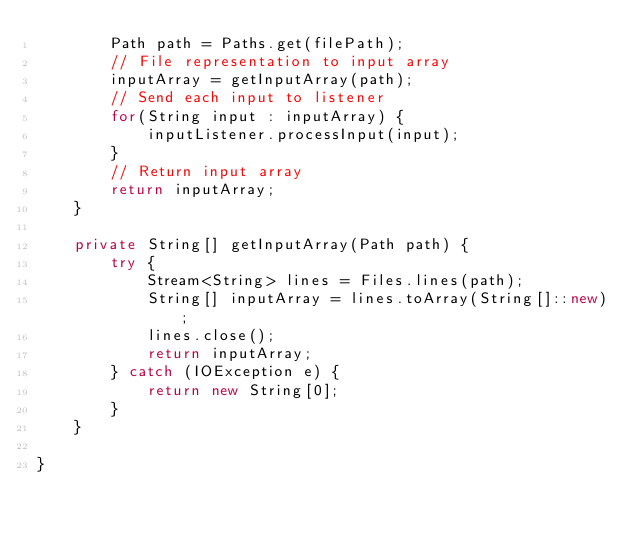<code> <loc_0><loc_0><loc_500><loc_500><_Java_>        Path path = Paths.get(filePath);
        // File representation to input array
        inputArray = getInputArray(path);
        // Send each input to listener
        for(String input : inputArray) {
            inputListener.processInput(input);
        }
        // Return input array
        return inputArray;
    }

    private String[] getInputArray(Path path) {
        try {
            Stream<String> lines = Files.lines(path);
            String[] inputArray = lines.toArray(String[]::new);
            lines.close();
            return inputArray;
        } catch (IOException e) {
            return new String[0];
        }
    }
    
}
</code> 